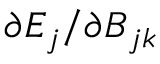<formula> <loc_0><loc_0><loc_500><loc_500>\partial E _ { j } / \partial B _ { j k }</formula> 